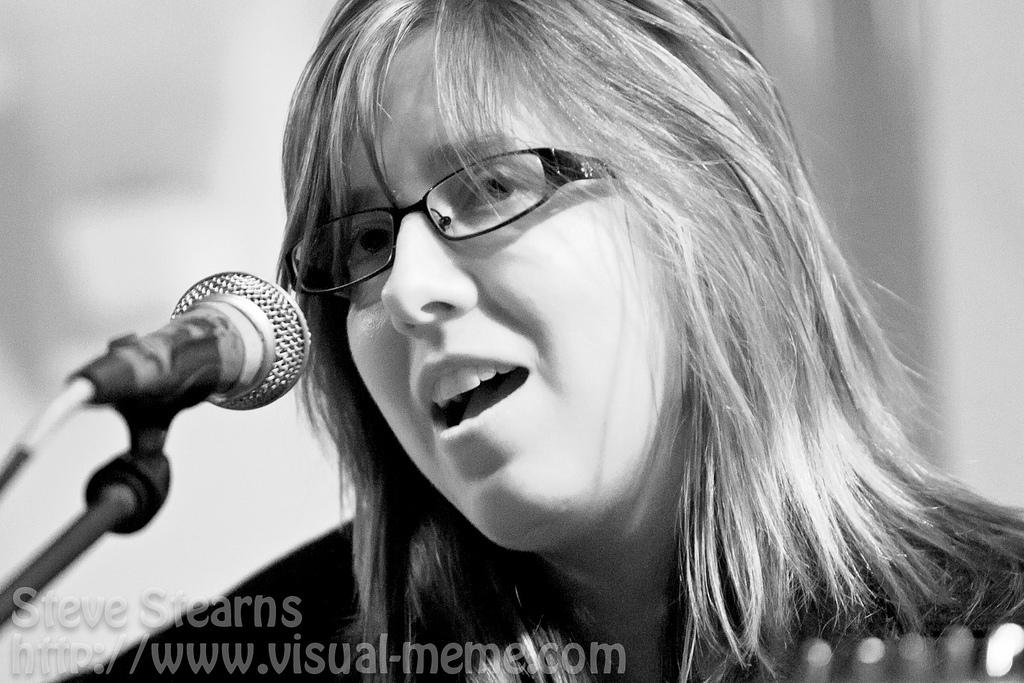Who is the main subject in the image? There is a woman in the image. What is the woman doing in the image? The woman is talking in the image. What object is present that might be related to the woman's activity? There is a microphone in the image. What color is the shirt the fly is wearing in the image? There is no fly or shirt present in the image. How many bells can be seen hanging from the woman's neck in the image? There are no bells visible in the image. 